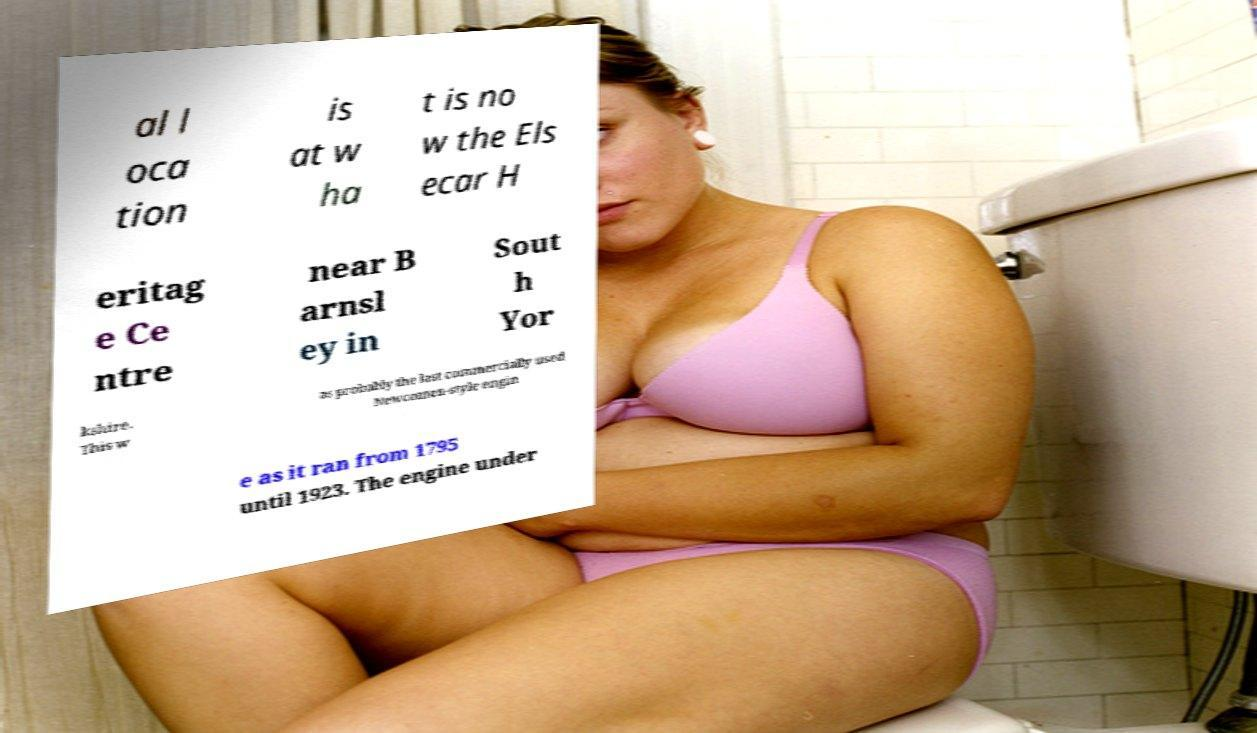I need the written content from this picture converted into text. Can you do that? al l oca tion is at w ha t is no w the Els ecar H eritag e Ce ntre near B arnsl ey in Sout h Yor kshire. This w as probably the last commercially used Newcomen-style engin e as it ran from 1795 until 1923. The engine under 